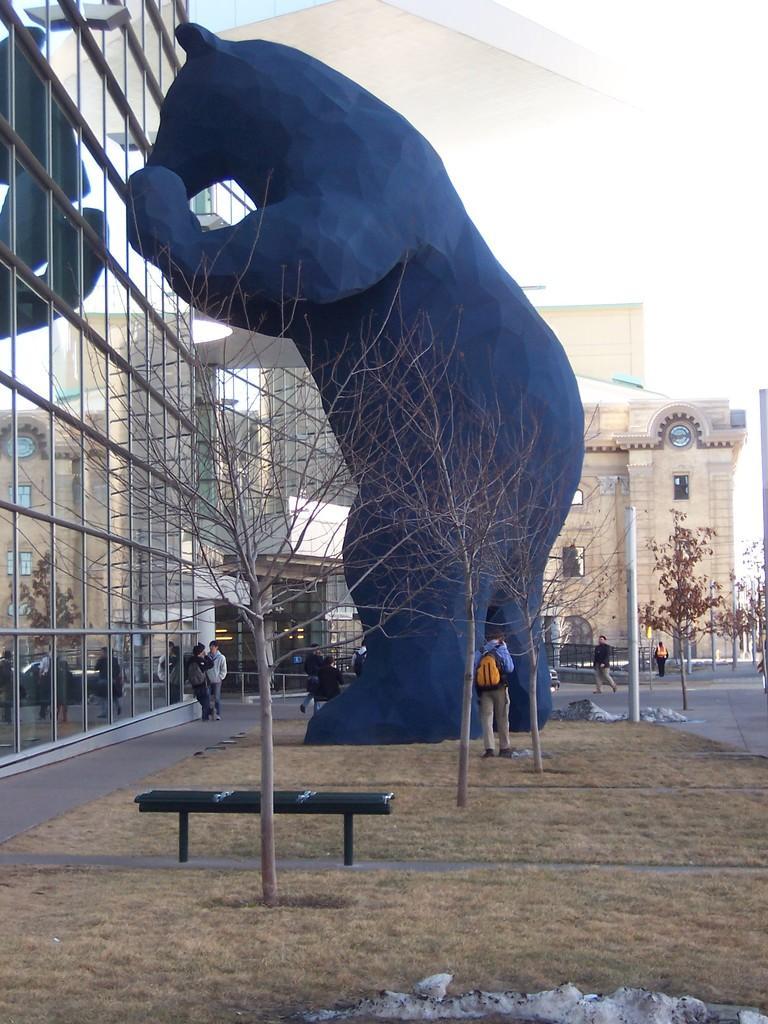Describe this image in one or two sentences. This image consists of few people. At the bottom, we can see dry grass on the ground. On the front, there is a bench. On the left, there is a building. In the background, we can see another building along with windows. In the front, we can see a statue of a bear. At the top, there is the sky. 